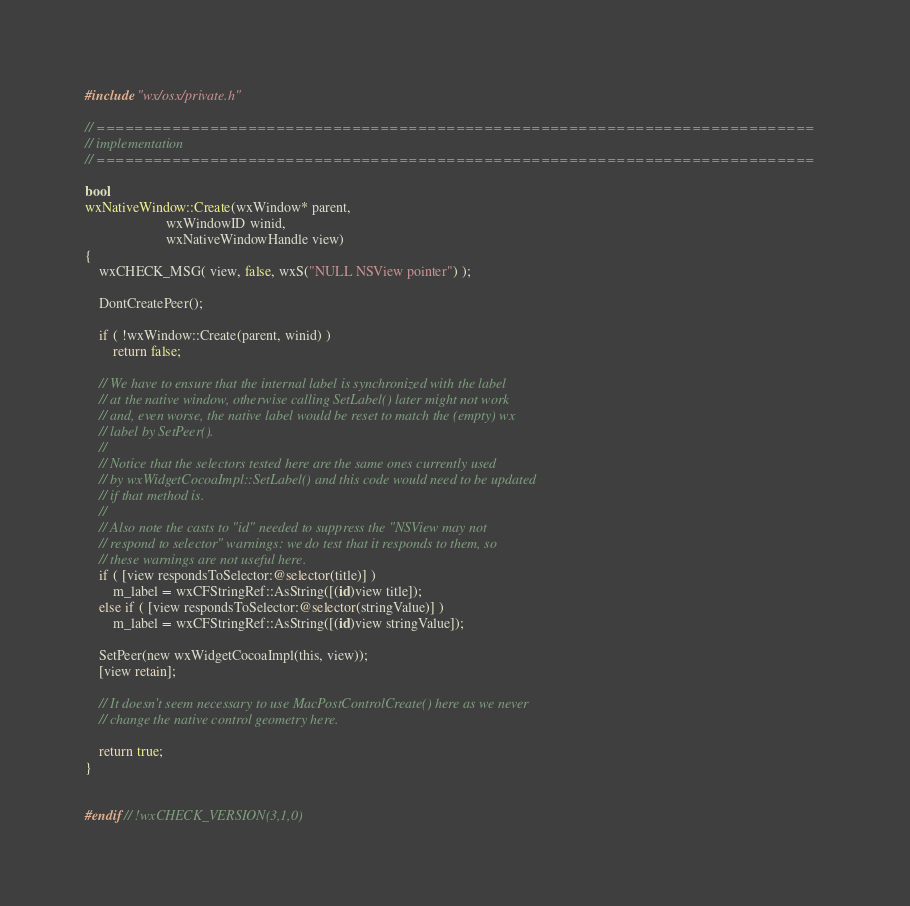Convert code to text. <code><loc_0><loc_0><loc_500><loc_500><_ObjectiveC_>
#include "wx/osx/private.h"

// ============================================================================
// implementation
// ============================================================================

bool
wxNativeWindow::Create(wxWindow* parent,
                       wxWindowID winid,
                       wxNativeWindowHandle view)
{
    wxCHECK_MSG( view, false, wxS("NULL NSView pointer") );

    DontCreatePeer();

    if ( !wxWindow::Create(parent, winid) )
        return false;

    // We have to ensure that the internal label is synchronized with the label
    // at the native window, otherwise calling SetLabel() later might not work
    // and, even worse, the native label would be reset to match the (empty) wx
    // label by SetPeer().
    //
    // Notice that the selectors tested here are the same ones currently used
    // by wxWidgetCocoaImpl::SetLabel() and this code would need to be updated
    // if that method is.
    //
    // Also note the casts to "id" needed to suppress the "NSView may not
    // respond to selector" warnings: we do test that it responds to them, so
    // these warnings are not useful here.
    if ( [view respondsToSelector:@selector(title)] )
        m_label = wxCFStringRef::AsString([(id)view title]);
    else if ( [view respondsToSelector:@selector(stringValue)] )
        m_label = wxCFStringRef::AsString([(id)view stringValue]);

    SetPeer(new wxWidgetCocoaImpl(this, view));
    [view retain];

    // It doesn't seem necessary to use MacPostControlCreate() here as we never
    // change the native control geometry here.

    return true;
}


#endif // !wxCHECK_VERSION(3,1,0)
</code> 